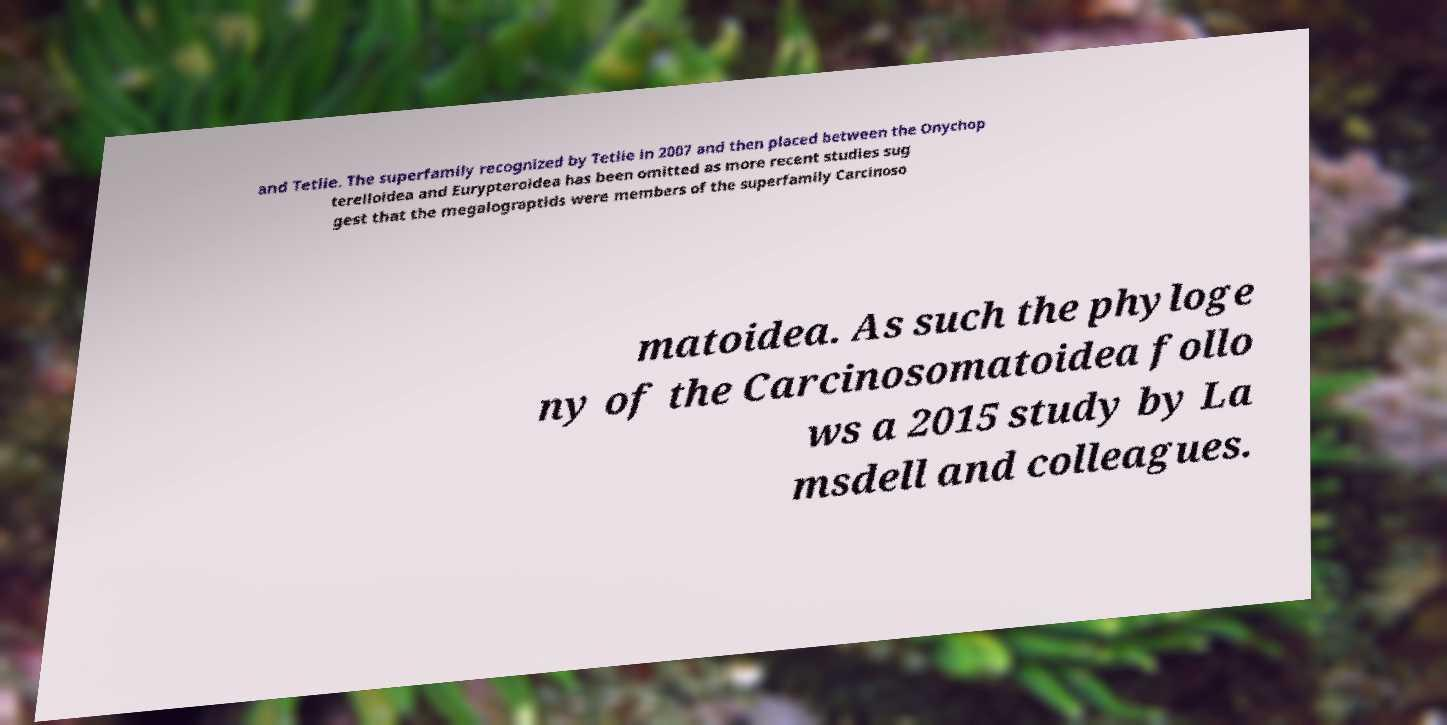Please read and relay the text visible in this image. What does it say? and Tetlie. The superfamily recognized by Tetlie in 2007 and then placed between the Onychop terelloidea and Eurypteroidea has been omitted as more recent studies sug gest that the megalograptids were members of the superfamily Carcinoso matoidea. As such the phyloge ny of the Carcinosomatoidea follo ws a 2015 study by La msdell and colleagues. 